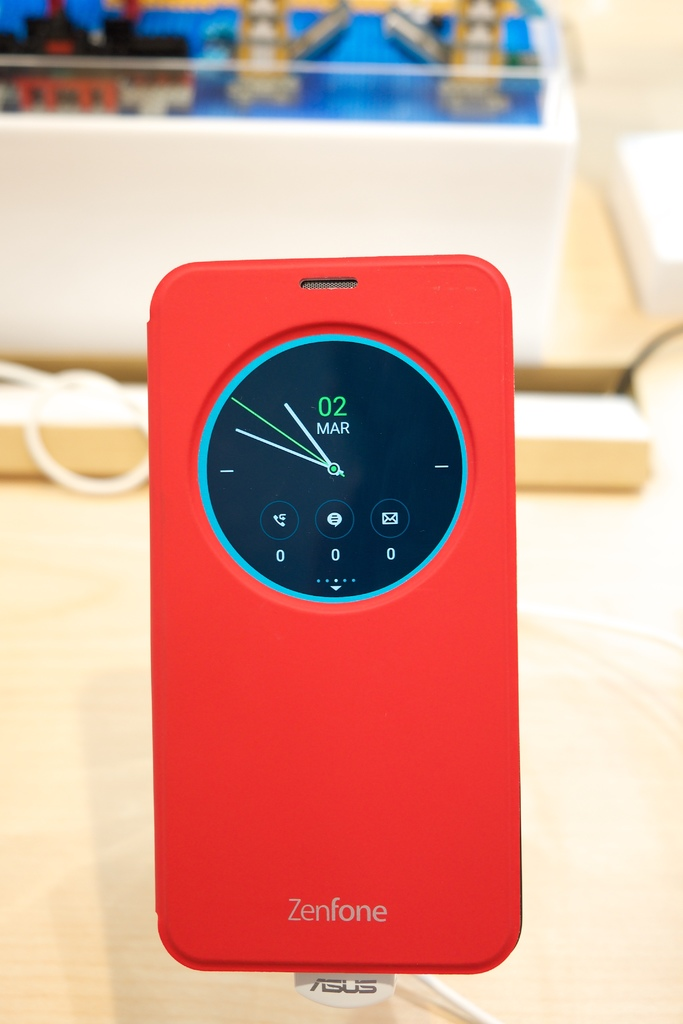Provide a one-sentence caption for the provided image. A striking red ASUS Zenfone case features an integrated circular display that shows a vibrant blue clock interface, marking the date as March 2nd. 